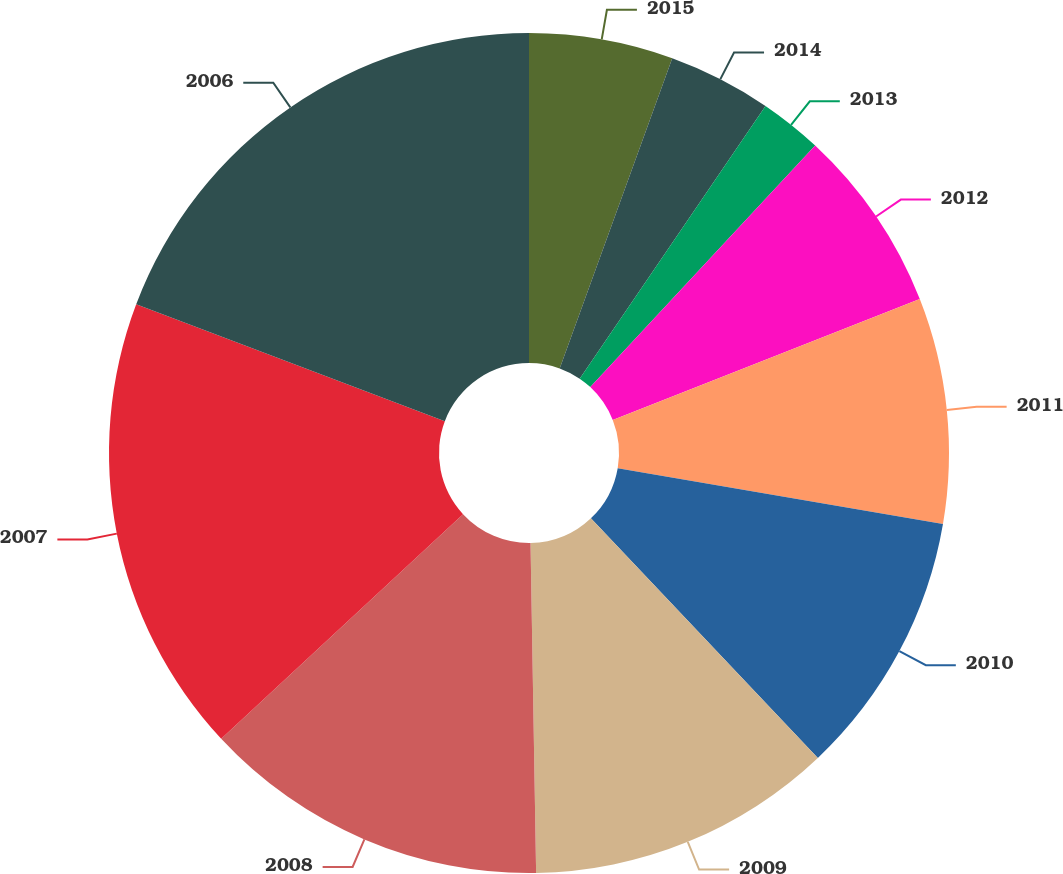<chart> <loc_0><loc_0><loc_500><loc_500><pie_chart><fcel>2015<fcel>2014<fcel>2013<fcel>2012<fcel>2011<fcel>2010<fcel>2009<fcel>2008<fcel>2007<fcel>2006<nl><fcel>5.54%<fcel>3.98%<fcel>2.41%<fcel>7.1%<fcel>8.67%<fcel>10.23%<fcel>11.8%<fcel>13.36%<fcel>17.67%<fcel>19.24%<nl></chart> 